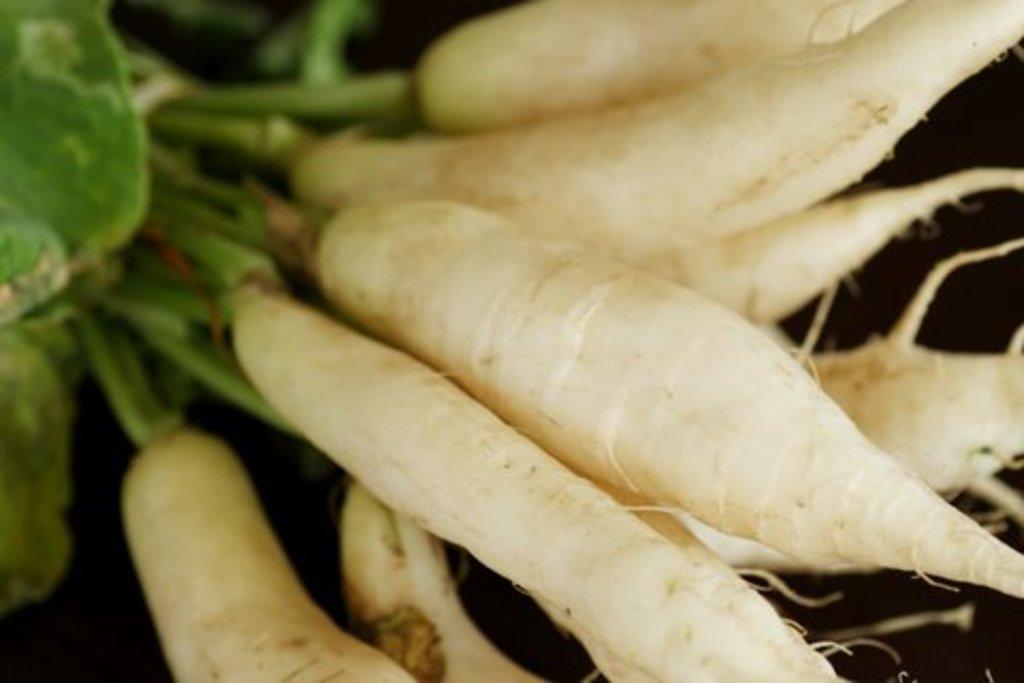Can you describe this image briefly? In this picture we can see some radishes. 